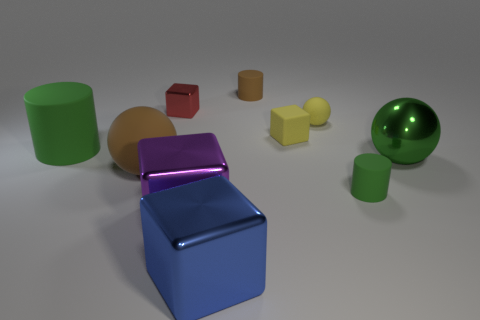Subtract all cylinders. How many objects are left? 7 Add 6 small balls. How many small balls exist? 7 Subtract 0 purple cylinders. How many objects are left? 10 Subtract all yellow blocks. Subtract all yellow matte cubes. How many objects are left? 8 Add 1 green things. How many green things are left? 4 